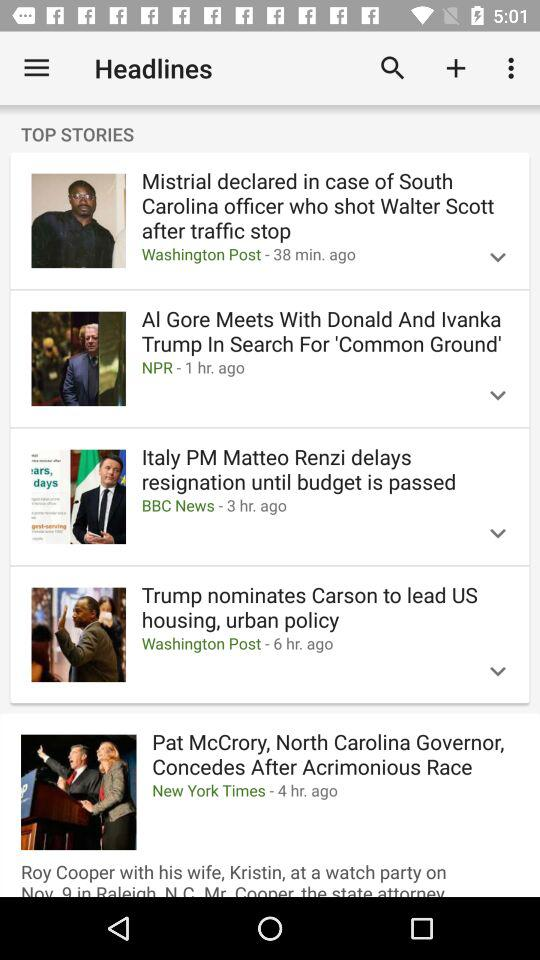How many articles have an arrow pointing down?
Answer the question using a single word or phrase. 4 